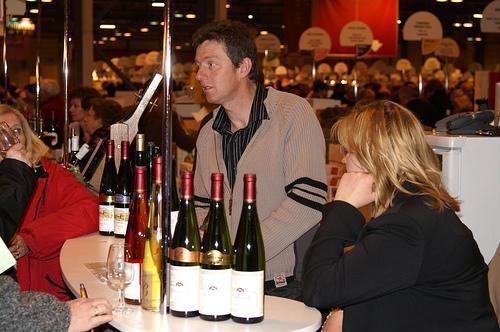How many male are there in this picture?
Give a very brief answer. 1. How many people are there?
Give a very brief answer. 5. How many bottles are there?
Give a very brief answer. 5. 